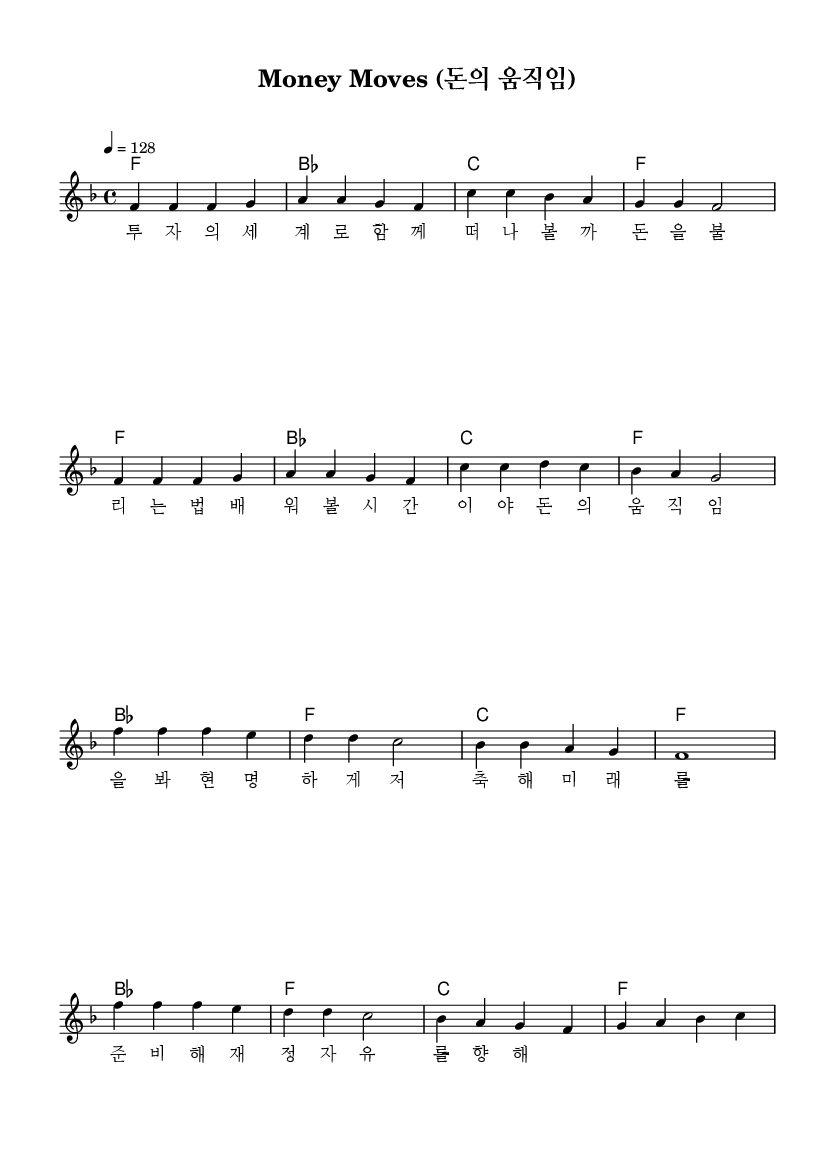What is the key signature of this music? The key signature is F major, indicated by one flat in the key signature area on the left side of the sheet music.
Answer: F major What is the time signature of this music? The time signature is 4/4, which can be found directly following the clef and key signature at the beginning of the score.
Answer: 4/4 What is the tempo marking of this music? The tempo marking is 128 beats per minute, specified in the tempo directive at the beginning of the piece with the symbol "4 = 128."
Answer: 128 How many measures are in the verse section? The verse section consists of 8 measures, as seen by counting the measure bars in the melody section under "Verse."
Answer: 8 What is the first note of the chorus? The first note of the chorus is F, which is indicated in the melody section where the chorus begins.
Answer: F Which chord appears at the end of the chorus? The chord at the end of the chorus is F, as indicated by the chord symbols written above the melody at the last measure of the chorus.
Answer: F What theme do the lyrics address? The lyrics address financial literacy and the importance of preparing financially, as indicated by the content of the lyrics in both the verse and chorus sections.
Answer: Financial literacy 